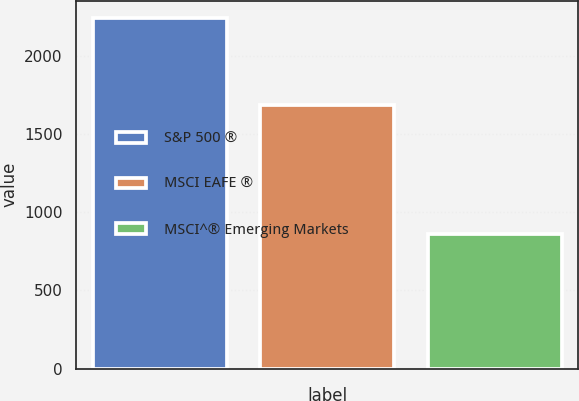<chart> <loc_0><loc_0><loc_500><loc_500><bar_chart><fcel>S&P 500 ®<fcel>MSCI EAFE ®<fcel>MSCI^® Emerging Markets<nl><fcel>2239<fcel>1684<fcel>862<nl></chart> 